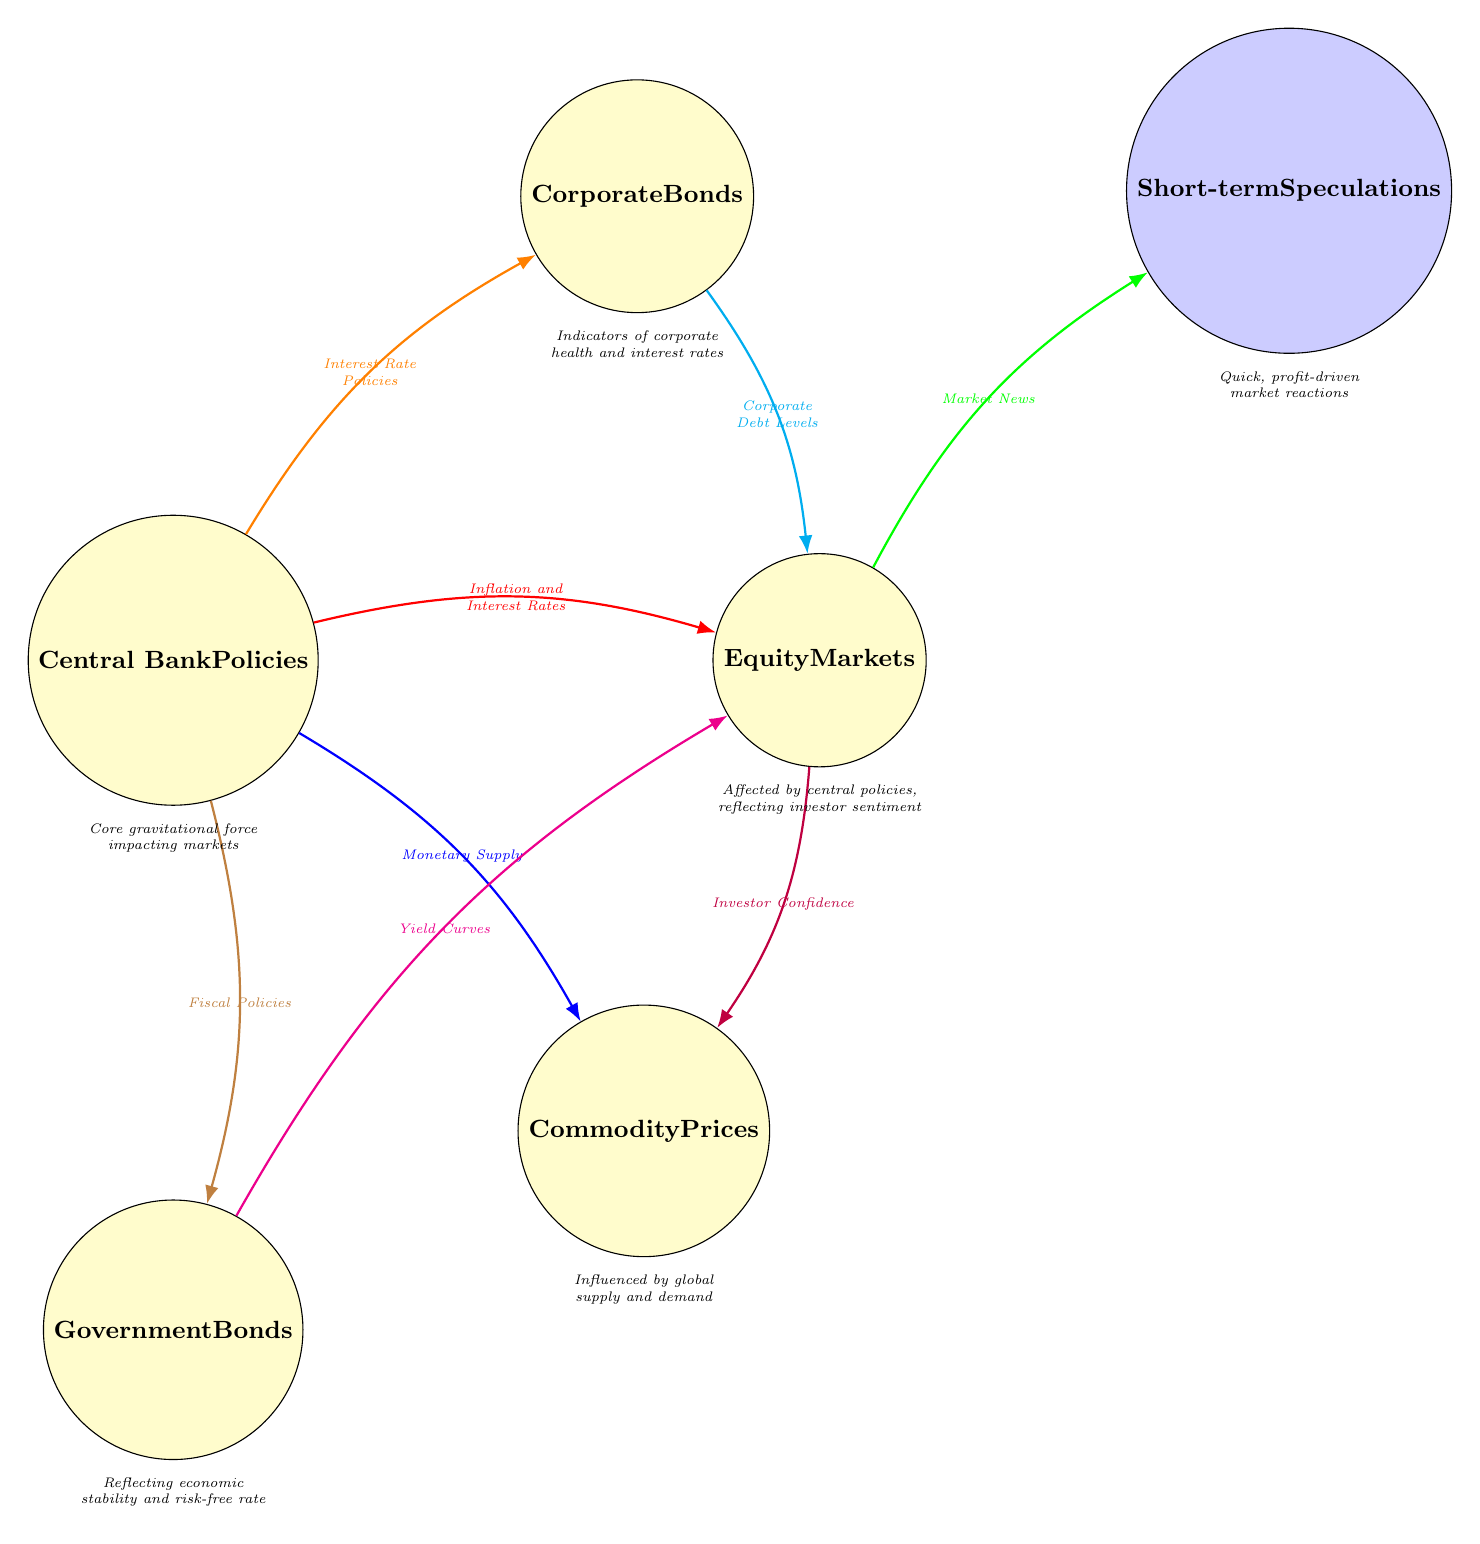What is the central node in the diagram? The central node, regarded as the main focal point in the diagram, is labeled "Central Bank Policies." This node is surrounded by the other nodes that illustrate how central bank actions impact various financial elements.
Answer: Central Bank Policies How many nodes represent market instruments in the diagram? In the diagram, the nodes that directly represent market instruments are "Equity Markets," "Commodity Prices," "Corporate Bonds," and "Government Bonds." Counting these gives a total of four market instrument nodes.
Answer: 4 What is the relationship between "Equity Markets" and "Short-term Speculations"? The relationship between "Equity Markets" and "Short-term Speculations" is indicated by a green arrow labeled "Market News." This connection shows that equity markets are impacted by market news, which in turn influences short-term speculations.
Answer: Market News Which node is affected by "Interest Rate Policies"? The node affected by "Interest Rate Policies" is "Corporate Bonds." The connection shown in the diagram indicates that interest rate policies from the central bank influence the corporate bond market.
Answer: Corporate Bonds What color represents the connection between "Central Bank Policies" and "Equity Markets"? The connection between "Central Bank Policies" and "Equity Markets" is represented by a red arrow. This color coding aids in identifying the specific influences central bank decisions have on the equity market.
Answer: Red What two factors influence "Commodity Prices"? "Commodity Prices" are influenced by two factors in the diagram: "Monetary Supply" from "Central Bank Policies," represented in blue, and "Investor Confidence" from "Equity Markets," represented in purple. This indicates a dual influence on commodity prices based on central bank policy actions and market sentiment.
Answer: Monetary Supply and Investor Confidence How is "Government Bonds" linked to "Equity Markets"? "Government Bonds" are linked to "Equity Markets" through a brown connection labeled "Fiscal Policies." This illustrates that fiscal policies impact both government bonds and the equity market, indicating interconnectedness between these financial instruments and government actions.
Answer: Fiscal Policies Which node depicts the fastest market reactions? The node that depicts the fastest market reactions is "Short-term Speculations." The labeled description below this node specifies that it involves quick, profit-driven market responses, thus indicating its alignment with rapid trading activities.
Answer: Short-term Speculations What does the red connection signify in this diagram? The red connection signifies the relationship labeled "Inflation and Interest Rates," which shows how these two factors are influenced by central bank policies and directly impact equity markets. Therefore, this color helps delineate the significance of monetary policy on market dynamics.
Answer: Inflation and Interest Rates 